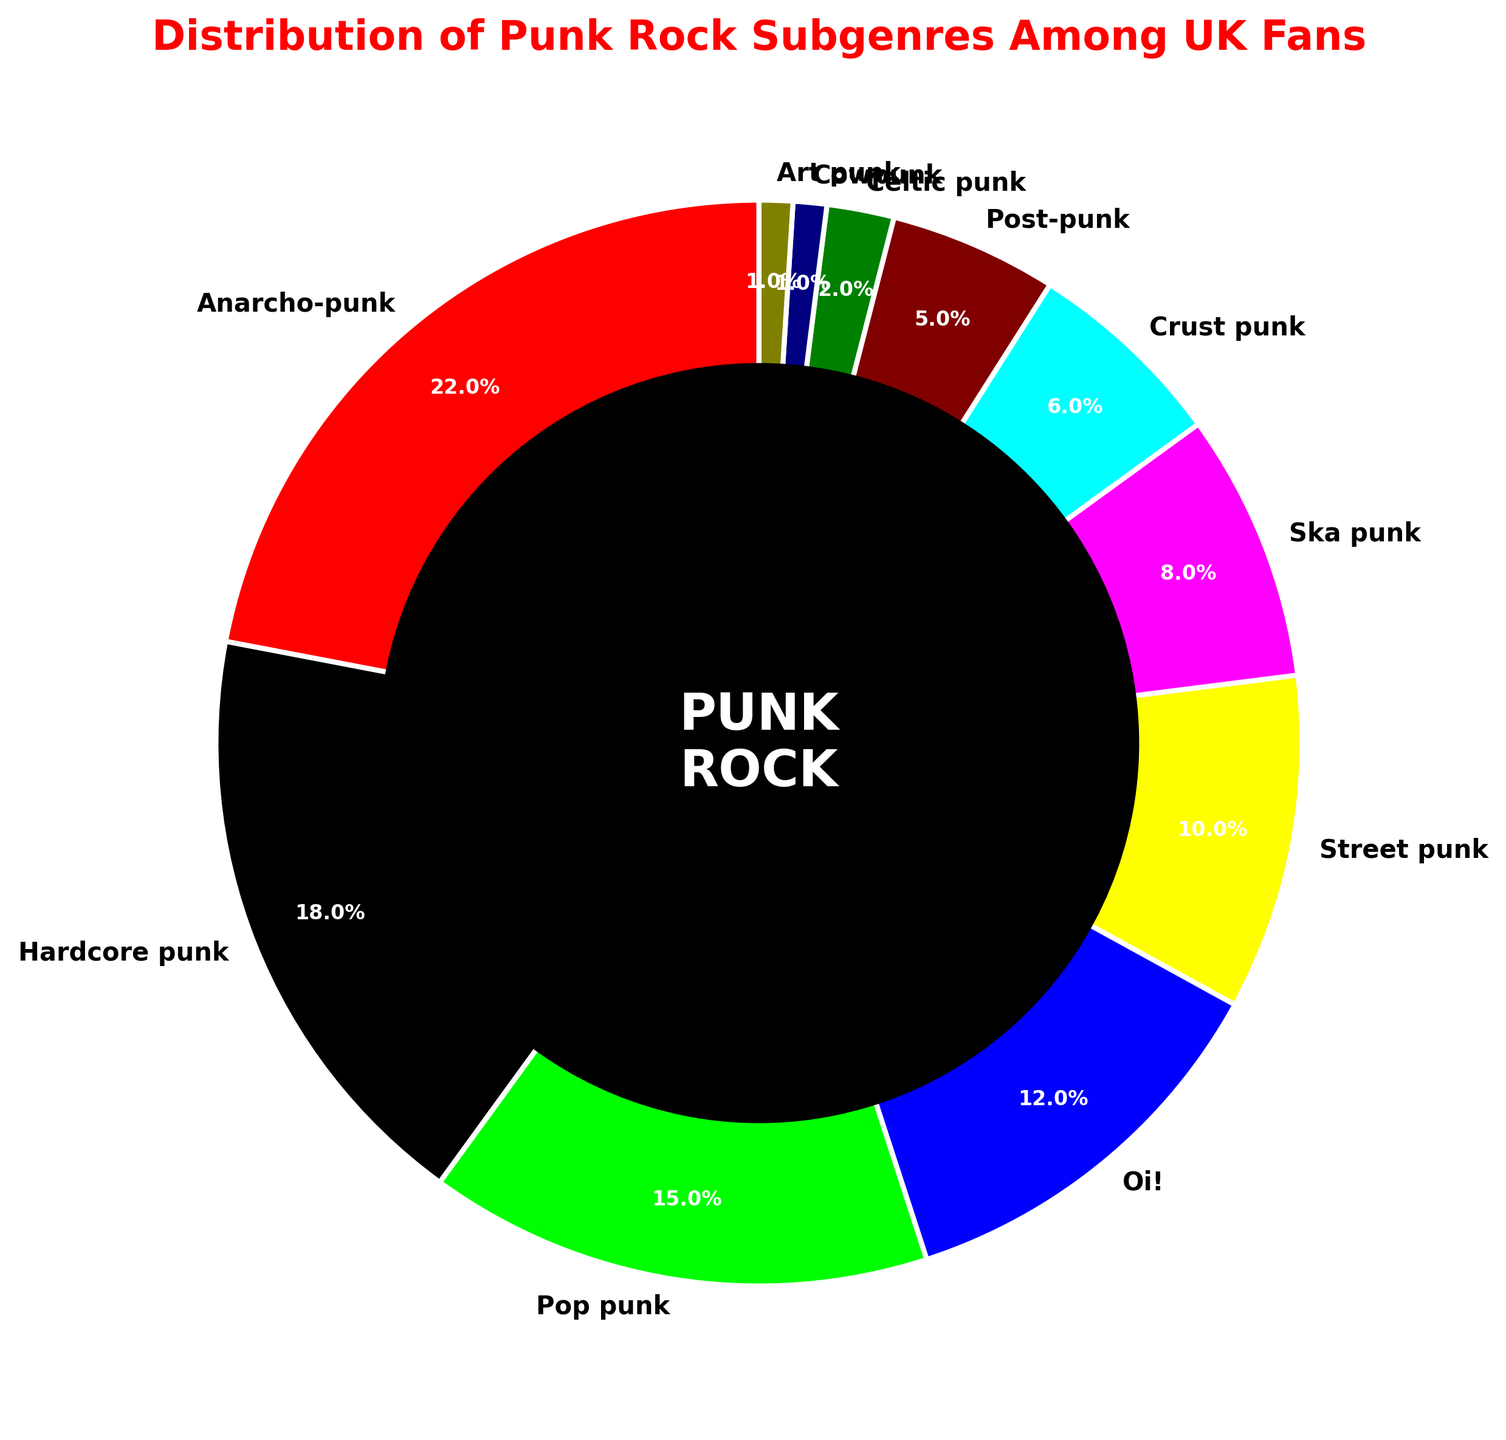which subgenre has the largest share among UK punk rock fans? The subgenre with the largest slice in the pie chart represents the largest share among UK punk rock fans. This subgenre is located at the top of the legend and pie chart. The label and percentage indicate that Anarcho-punk has the largest share.
Answer: Anarcho-punk what is the combined percentage of Oi! and Ska punk? The percentages for Oi! and Ska punk are 12% and 8% respectively. Adding these two percentages together gives 12% + 8% = 20%.
Answer: 20% how many subgenres make up more than 10% each of the distribution? By examining the labels and percentages around the pie chart, Anarcho-punk (22%), Hardcore punk (18%), and Pop punk (15%) each make up more than 10% of the distribution. The counts are visually confirmed with three labels showing percentages above 10%.
Answer: 3 which subgenres have the smallest and largest slices on the chart, and what are their percentages? The label and percentage for the smallest slice is Art punk with 1%. The label and percentage for the largest slice is Anarcho-punk with 22%.
Answer: Art punk (1%), Anarcho-punk (22%) what is the difference in percentage between Street punk and Crust punk? The percentage for Street punk is 10% and for Crust punk is 6%. Subtracting the Crust punk percentage from the Street punk percentage gives 10% - 6% = 4%.
Answer: 4% among all subgenres, what is the exact total percentage for the top three subgenres? The top three subgenres by percentage are Anarcho-punk (22%), Hardcore punk (18%), and Pop punk (15%). Adding these percentages together gives 22% + 18% + 15% = 55%.
Answer: 55% which subgenre has the same percentage as Cowpunk and what is the percentage? The subgenre with the same percentage as Cowpunk (1%) is Art punk (1%).
Answer: Art punk (1%) how does the size of the Post-punk slice compare to the Ska punk slice? The Post-punk slice represents 5%, and the Ska punk slice represents 8%. Therefore, the Ska punk slice is larger than the Post-punk slice.
Answer: Ska punk is larger what percentage do the subgenres with less than 5% each contribute? The subgenres with less than 5% are Cowpunk (1%) and Art punk (1%). Adding these percentages gives 1% + 1% = 2%.
Answer: 2% are there more subgenres with 10% or higher than those with 5% or lower? The subgenres with 10% or higher are Anarcho-punk (22%), Hardcore punk (18%), Pop punk (15%), and Street punk (10%) making a total of 4 subgenres. The subgenres with 5% or lower are Crust punk (6%), Post-punk (5%), Celtic punk (2%), Cowpunk (1%), and Art punk (1%), making a total of 5 subgenres.
Answer: No 